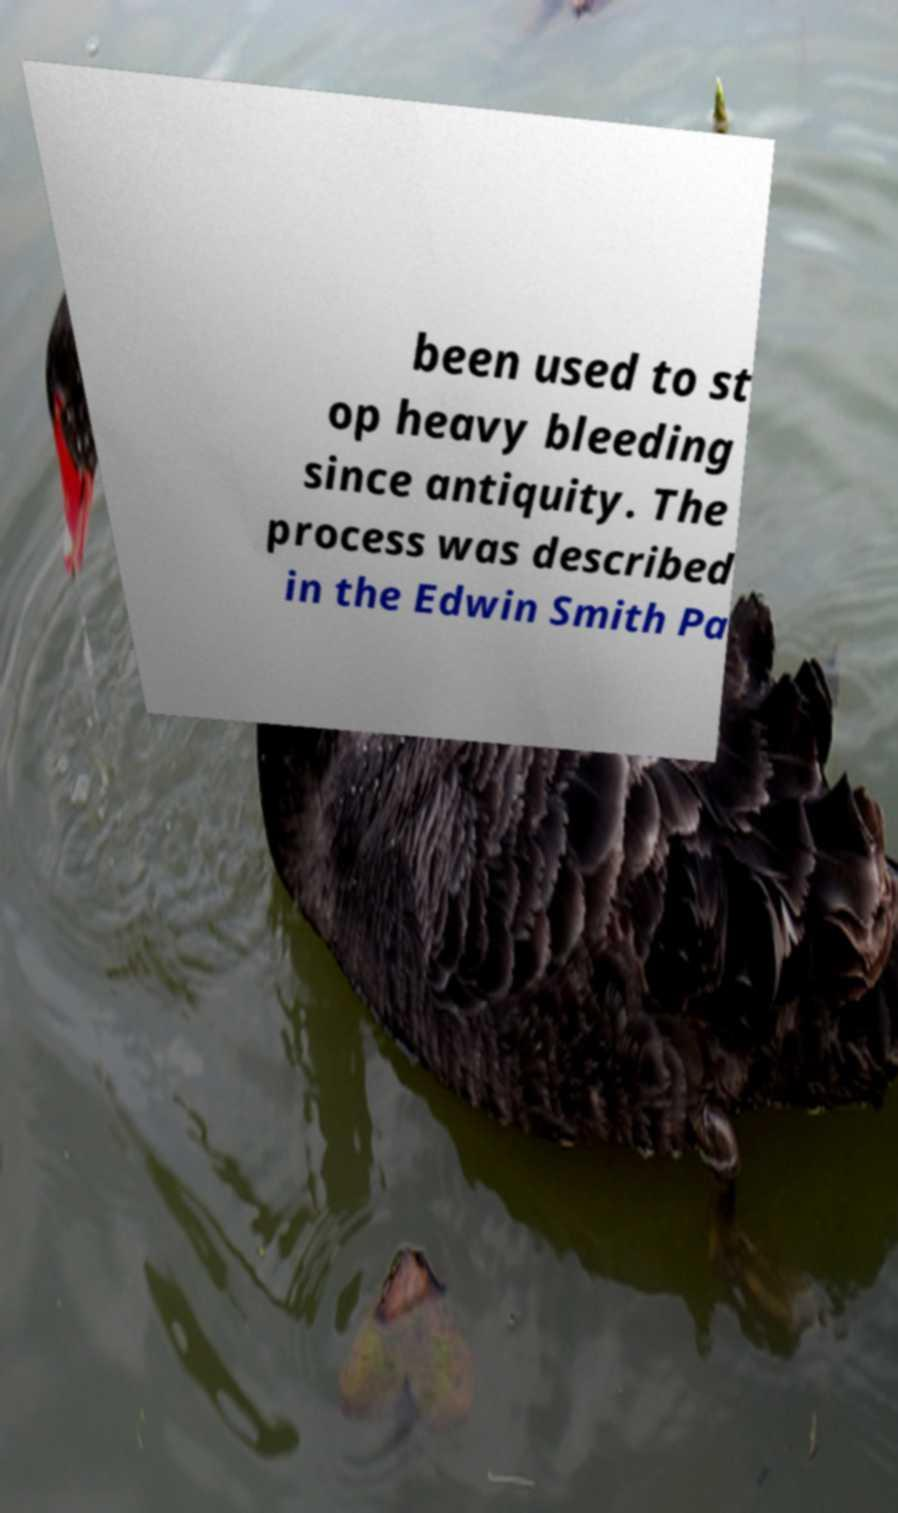Can you accurately transcribe the text from the provided image for me? been used to st op heavy bleeding since antiquity. The process was described in the Edwin Smith Pa 